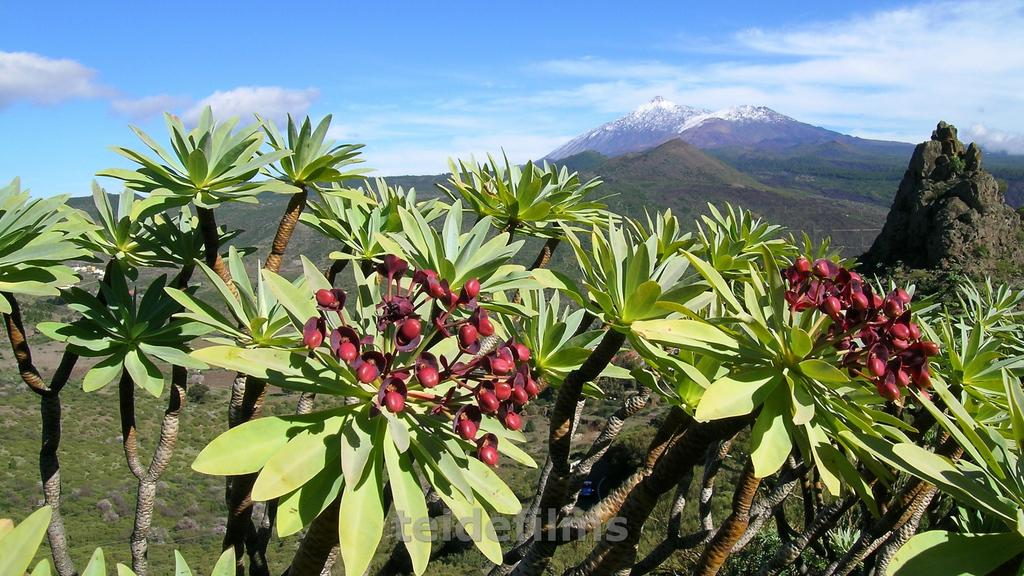What type of vegetation is present in the image? There are trees with flowers in the image. What can be seen in the background of the image? Hills are visible in the background of the image. What is visible in the sky in the image? Clouds are present in the sky. Can you describe the overall setting of the image? The image features trees with flowers, hills in the background, and a sky with clouds. Is there a writer sitting at a desk in the image? There is no writer or desk present in the image; it features trees with flowers, hills, and a sky with clouds. 